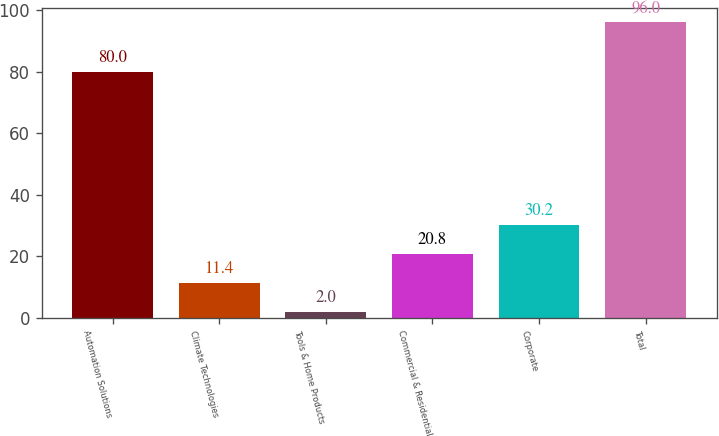<chart> <loc_0><loc_0><loc_500><loc_500><bar_chart><fcel>Automation Solutions<fcel>Climate Technologies<fcel>Tools & Home Products<fcel>Commercial & Residential<fcel>Corporate<fcel>Total<nl><fcel>80<fcel>11.4<fcel>2<fcel>20.8<fcel>30.2<fcel>96<nl></chart> 